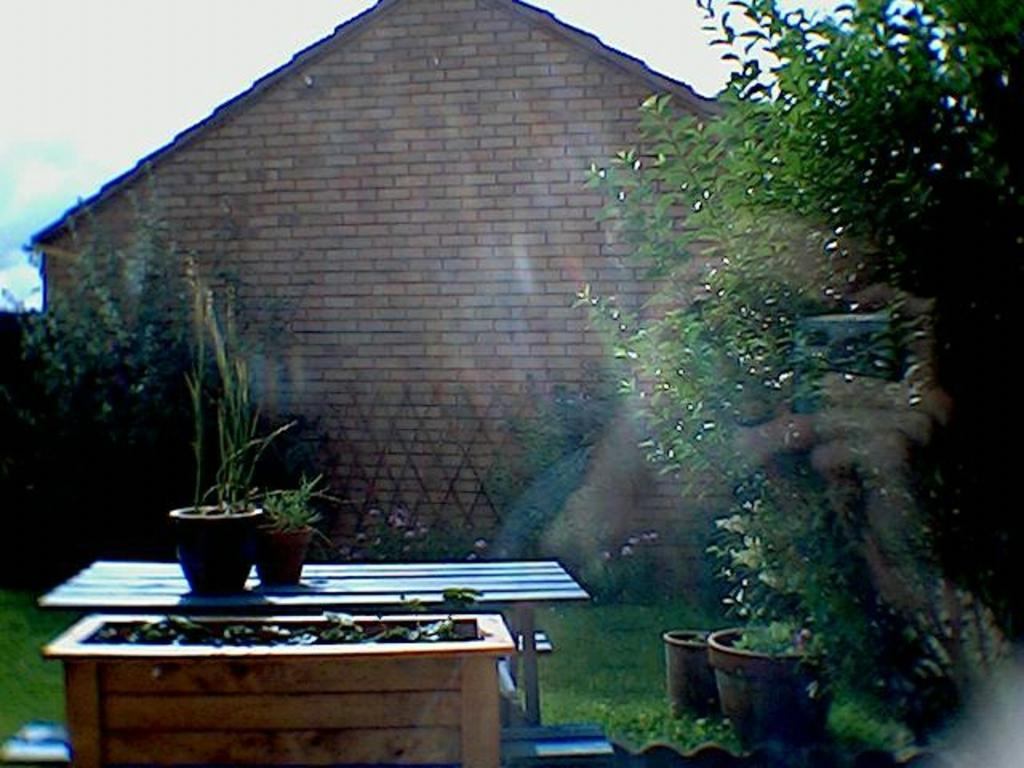What type of vegetation is on the right side of the image? There is a tree on the right side of the image. What is located in the center of the image? There is a table in the center of the image. What is placed on the table in the image? There are plants placed on the table. What can be seen in the background of the image? There is a house, a fence, and the sky visible in the background of the image. How many legs does the insect have in the image? There is no insect present in the image. What type of wood is used to make the fence in the image? The image does not provide information about the type of wood used for the fence. 